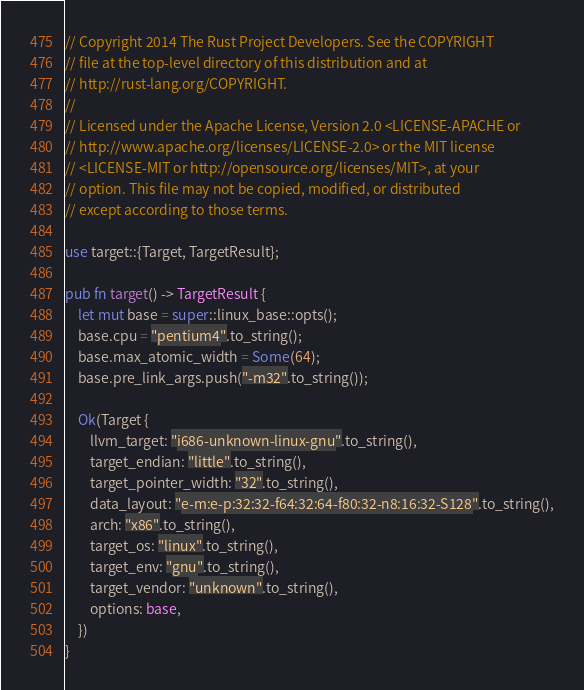Convert code to text. <code><loc_0><loc_0><loc_500><loc_500><_Rust_>// Copyright 2014 The Rust Project Developers. See the COPYRIGHT
// file at the top-level directory of this distribution and at
// http://rust-lang.org/COPYRIGHT.
//
// Licensed under the Apache License, Version 2.0 <LICENSE-APACHE or
// http://www.apache.org/licenses/LICENSE-2.0> or the MIT license
// <LICENSE-MIT or http://opensource.org/licenses/MIT>, at your
// option. This file may not be copied, modified, or distributed
// except according to those terms.

use target::{Target, TargetResult};

pub fn target() -> TargetResult {
    let mut base = super::linux_base::opts();
    base.cpu = "pentium4".to_string();
    base.max_atomic_width = Some(64);
    base.pre_link_args.push("-m32".to_string());

    Ok(Target {
        llvm_target: "i686-unknown-linux-gnu".to_string(),
        target_endian: "little".to_string(),
        target_pointer_width: "32".to_string(),
        data_layout: "e-m:e-p:32:32-f64:32:64-f80:32-n8:16:32-S128".to_string(),
        arch: "x86".to_string(),
        target_os: "linux".to_string(),
        target_env: "gnu".to_string(),
        target_vendor: "unknown".to_string(),
        options: base,
    })
}
</code> 